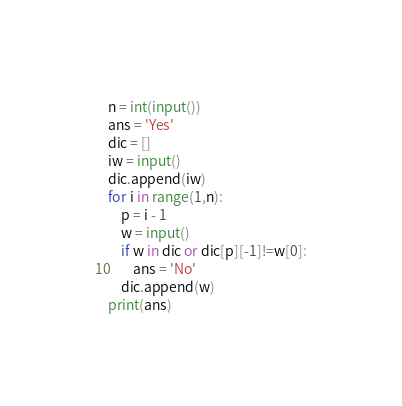<code> <loc_0><loc_0><loc_500><loc_500><_Python_>n = int(input())
ans = 'Yes'
dic = []
iw = input()
dic.append(iw)
for i in range(1,n):
    p = i - 1
    w = input()
    if w in dic or dic[p][-1]!=w[0]:
        ans = 'No'
    dic.append(w)
print(ans)
</code> 